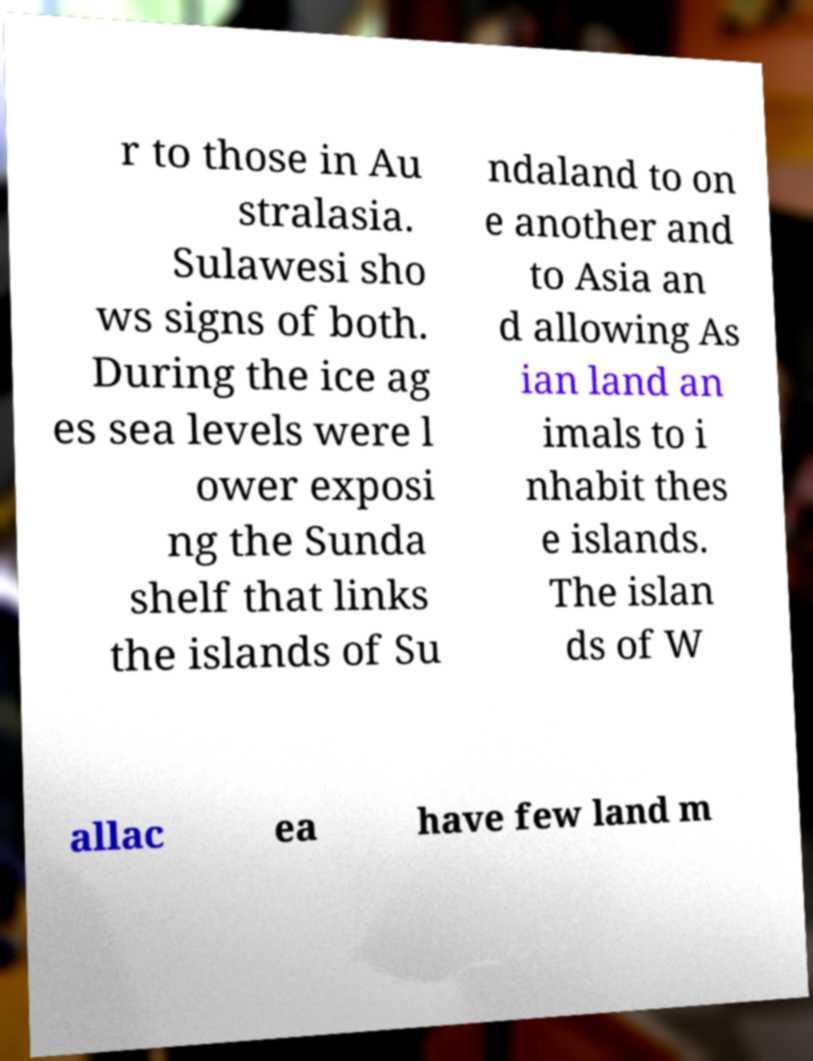What messages or text are displayed in this image? I need them in a readable, typed format. r to those in Au stralasia. Sulawesi sho ws signs of both. During the ice ag es sea levels were l ower exposi ng the Sunda shelf that links the islands of Su ndaland to on e another and to Asia an d allowing As ian land an imals to i nhabit thes e islands. The islan ds of W allac ea have few land m 